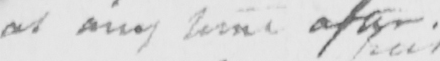Transcribe the text shown in this historical manuscript line. at any other time after . 